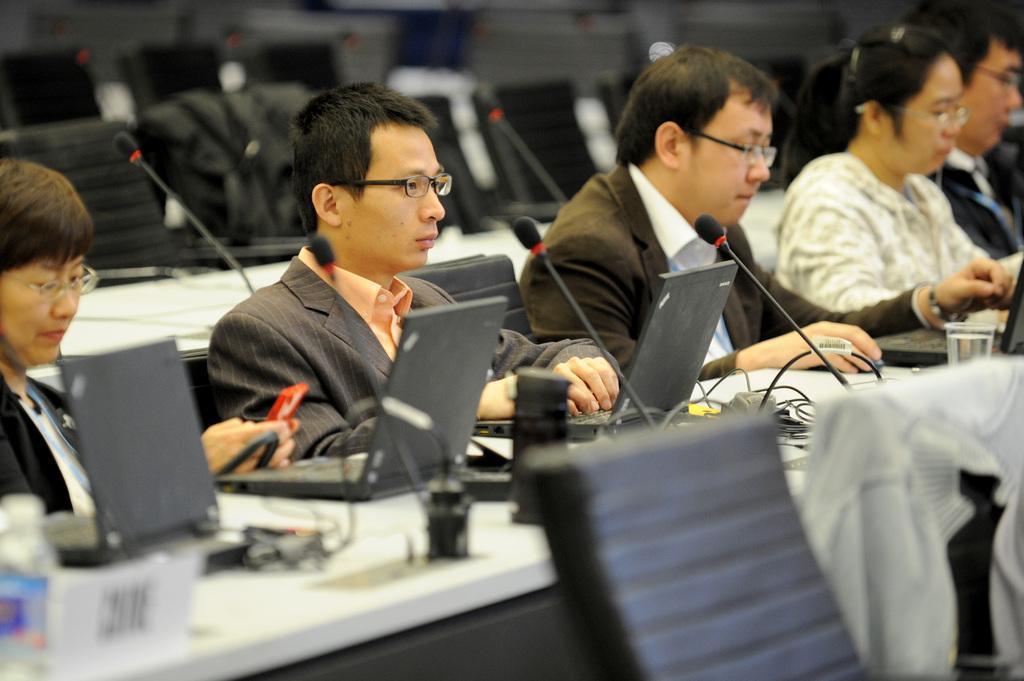Please provide a concise description of this image. In this image, we can see a few people sitting. We can also see some chairs. We can see some tables and a few devices on them. We can also see some clothes. 